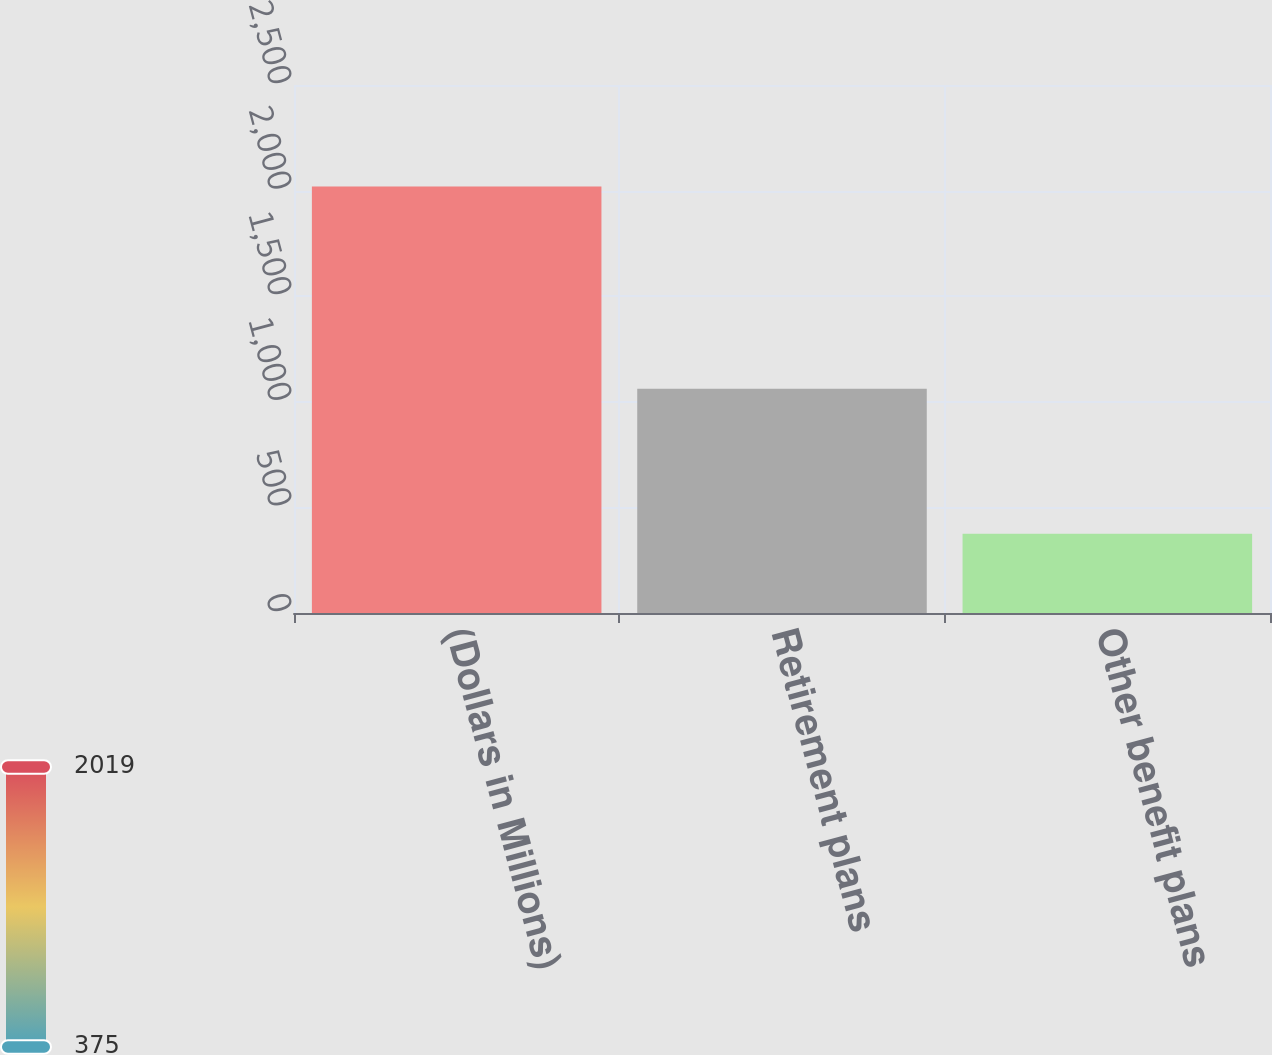<chart> <loc_0><loc_0><loc_500><loc_500><bar_chart><fcel>(Dollars in Millions)<fcel>Retirement plans<fcel>Other benefit plans<nl><fcel>2019<fcel>1062<fcel>375<nl></chart> 